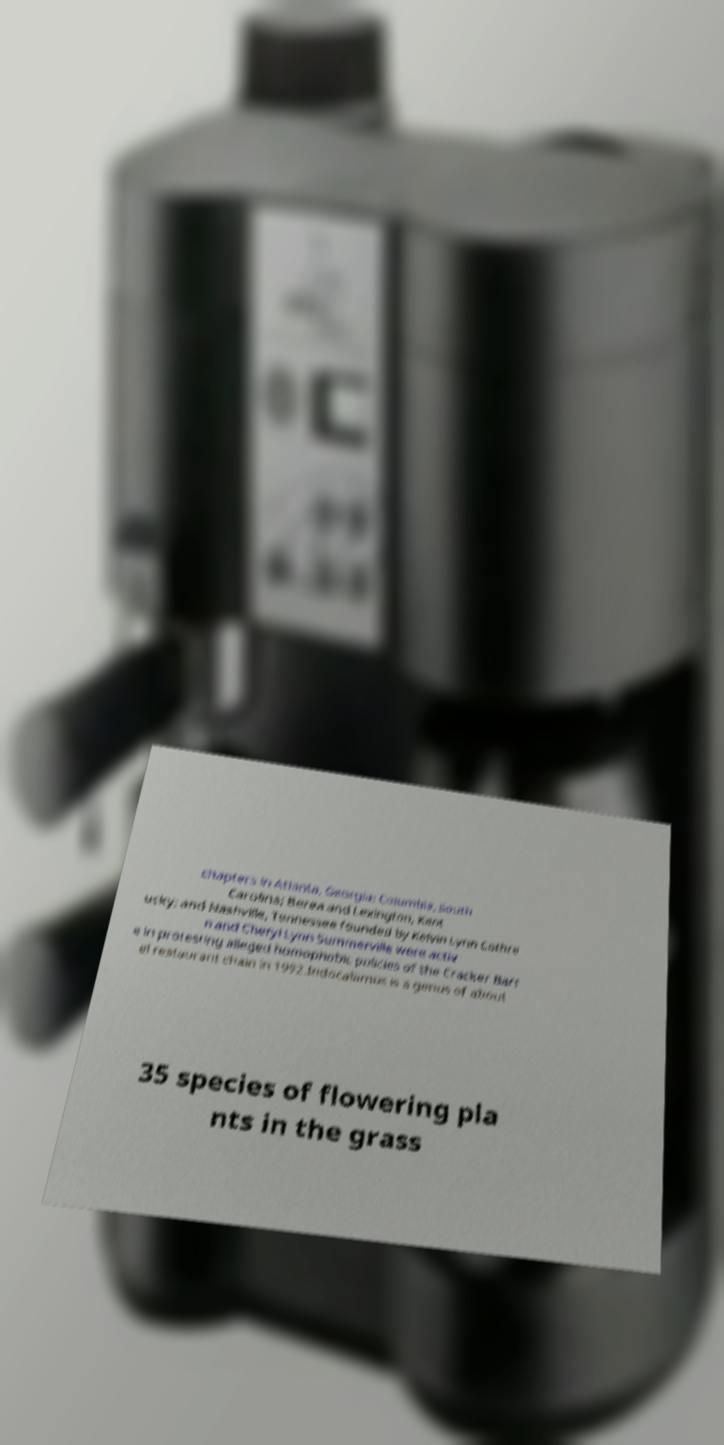Please identify and transcribe the text found in this image. chapters in Atlanta, Georgia; Columbia, South Carolina; Berea and Lexington, Kent ucky; and Nashville, Tennessee founded by Kelvin Lynn Cothre n and Cheryl Lynn Summerville were activ e in protesting alleged homophobic policies of the Cracker Barr el restaurant chain in 1992.Indocalamus is a genus of about 35 species of flowering pla nts in the grass 